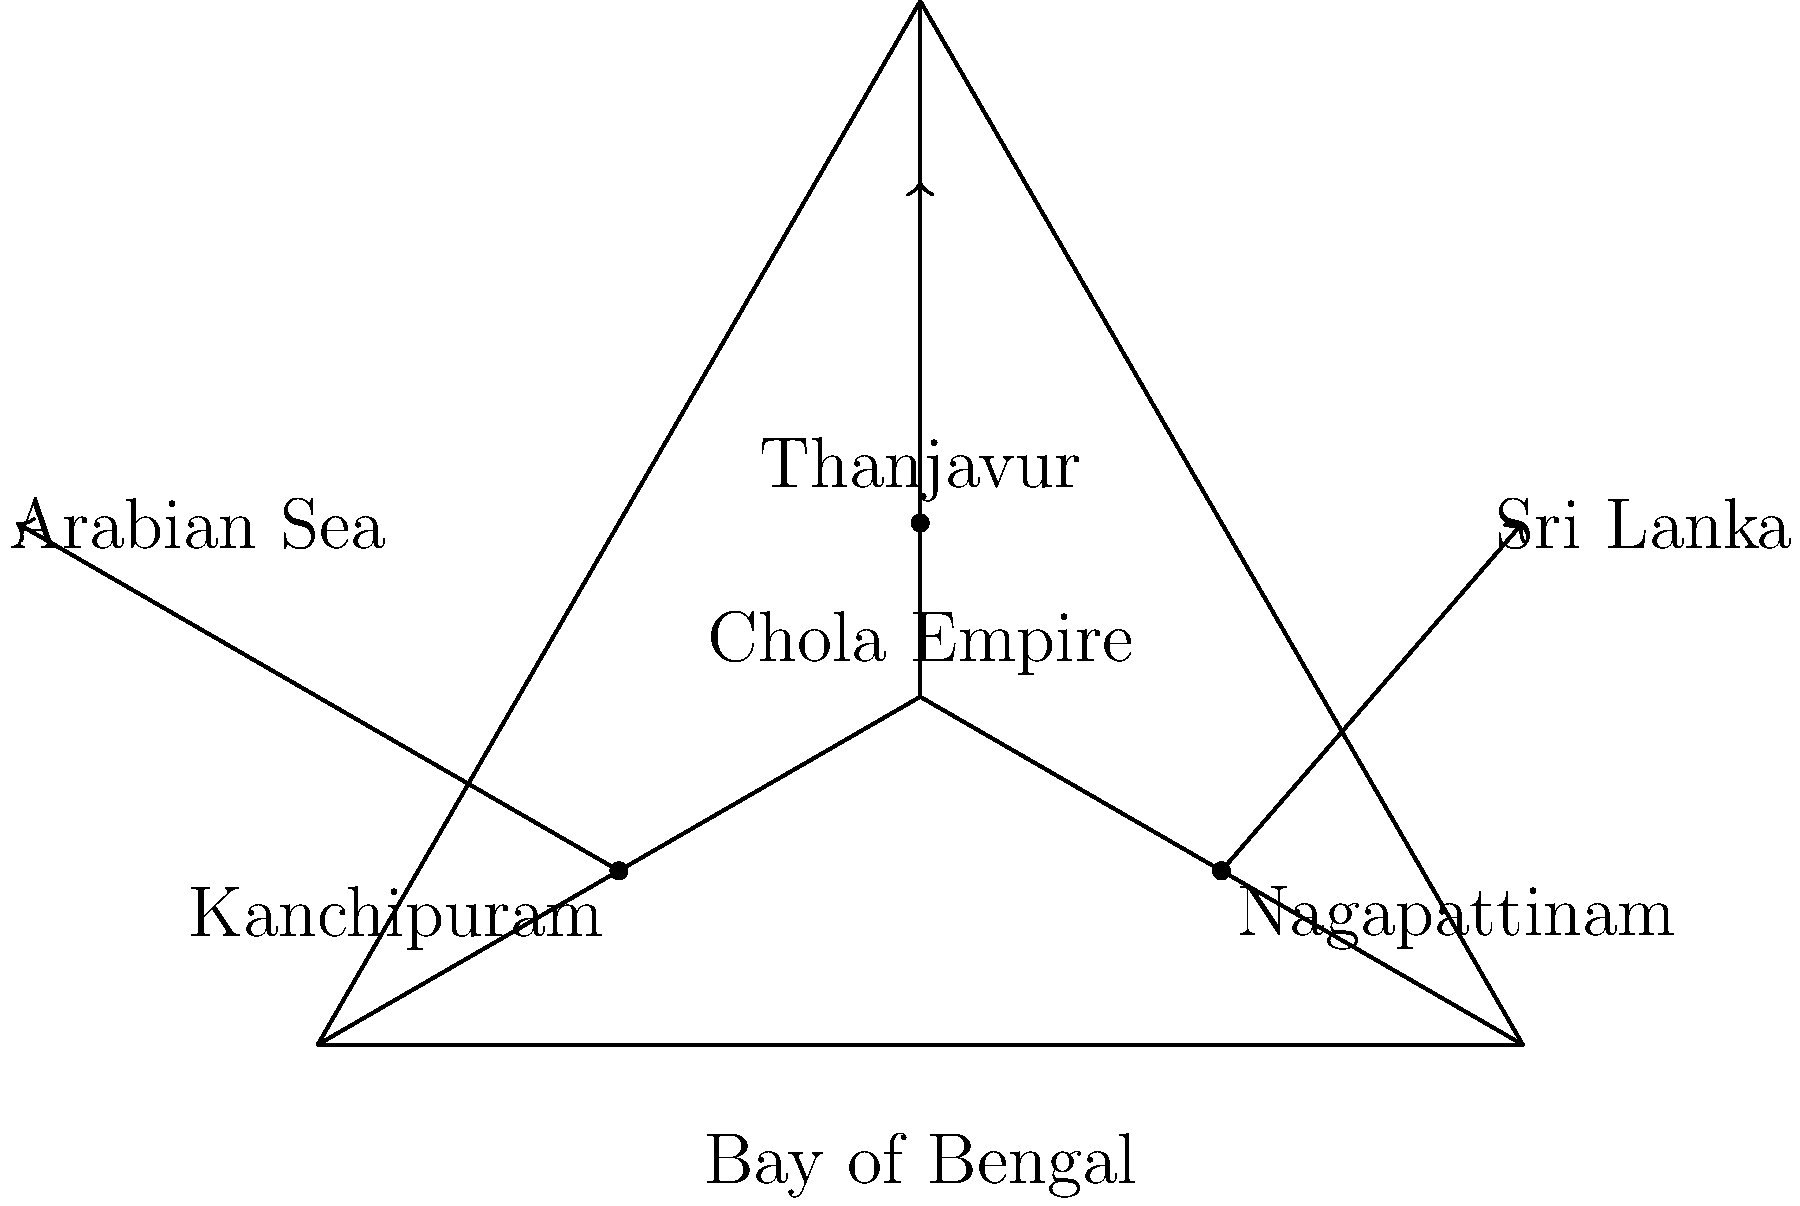Based on the diagram of the Chola Empire's trade routes, which city served as the primary port for maritime trade with Southeast Asia and acted as a gateway for the empire's naval expeditions? To answer this question, let's analyze the diagram step-by-step:

1. The diagram shows a triangular representation of the Chola Empire's geographical area, with the Bay of Bengal, Arabian Sea, and Sri Lanka marked.

2. Three important cities are marked within the empire:
   a) Kanchipuram
   b) Thanjavur
   c) Nagapattinam

3. Arrows indicate trade routes from these cities:
   a) Kanchipuram has an arrow pointing towards the Arabian Sea
   b) Thanjavur has an arrow pointing north, likely indicating inland trade
   c) Nagapattinam has an arrow pointing towards Sri Lanka and beyond

4. The arrow from Nagapattinam is the only one pointing towards the sea route that would lead to Southeast Asia.

5. Historically, Nagapattinam was indeed the primary port city of the Chola Empire, known for its maritime trade with Southeast Asian kingdoms and as a launching point for naval expeditions.

Given this analysis, we can conclude that Nagapattinam was the city that served as the primary port for maritime trade with Southeast Asia and acted as a gateway for the empire's naval expeditions.
Answer: Nagapattinam 